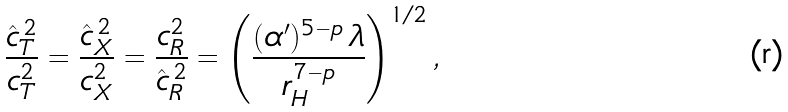Convert formula to latex. <formula><loc_0><loc_0><loc_500><loc_500>\frac { \hat { c } _ { T } ^ { \, 2 } } { c _ { T } ^ { 2 } } = \frac { \hat { c } _ { X } ^ { \, 2 } } { c _ { X } ^ { 2 } } = \frac { c _ { R } ^ { 2 } } { \hat { c } _ { R } ^ { \, 2 } } = \left ( \frac { ( \alpha ^ { \prime } ) ^ { 5 - p } \, \lambda } { r _ { H } ^ { 7 - p } } \right ) ^ { 1 / 2 } ,</formula> 